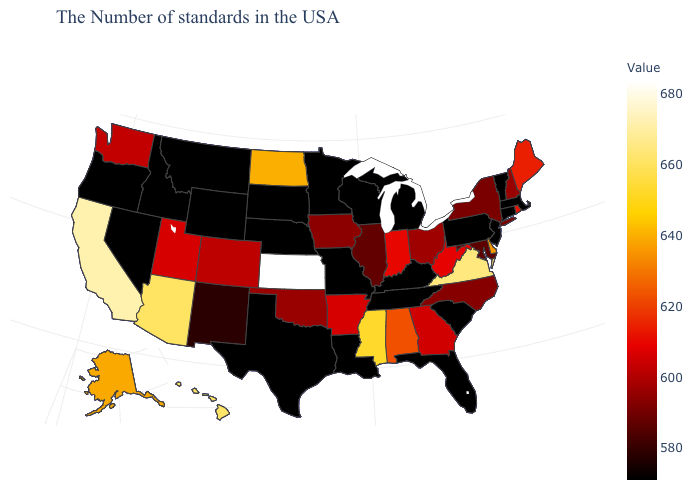Which states hav the highest value in the Northeast?
Short answer required. Maine. Is the legend a continuous bar?
Concise answer only. Yes. Among the states that border Kansas , which have the highest value?
Write a very short answer. Colorado. Does Virginia have the highest value in the South?
Be succinct. Yes. Does Michigan have the highest value in the MidWest?
Write a very short answer. No. Which states have the lowest value in the MidWest?
Answer briefly. Michigan, Wisconsin, Missouri, Minnesota, Nebraska, South Dakota. Which states have the highest value in the USA?
Quick response, please. Kansas. 